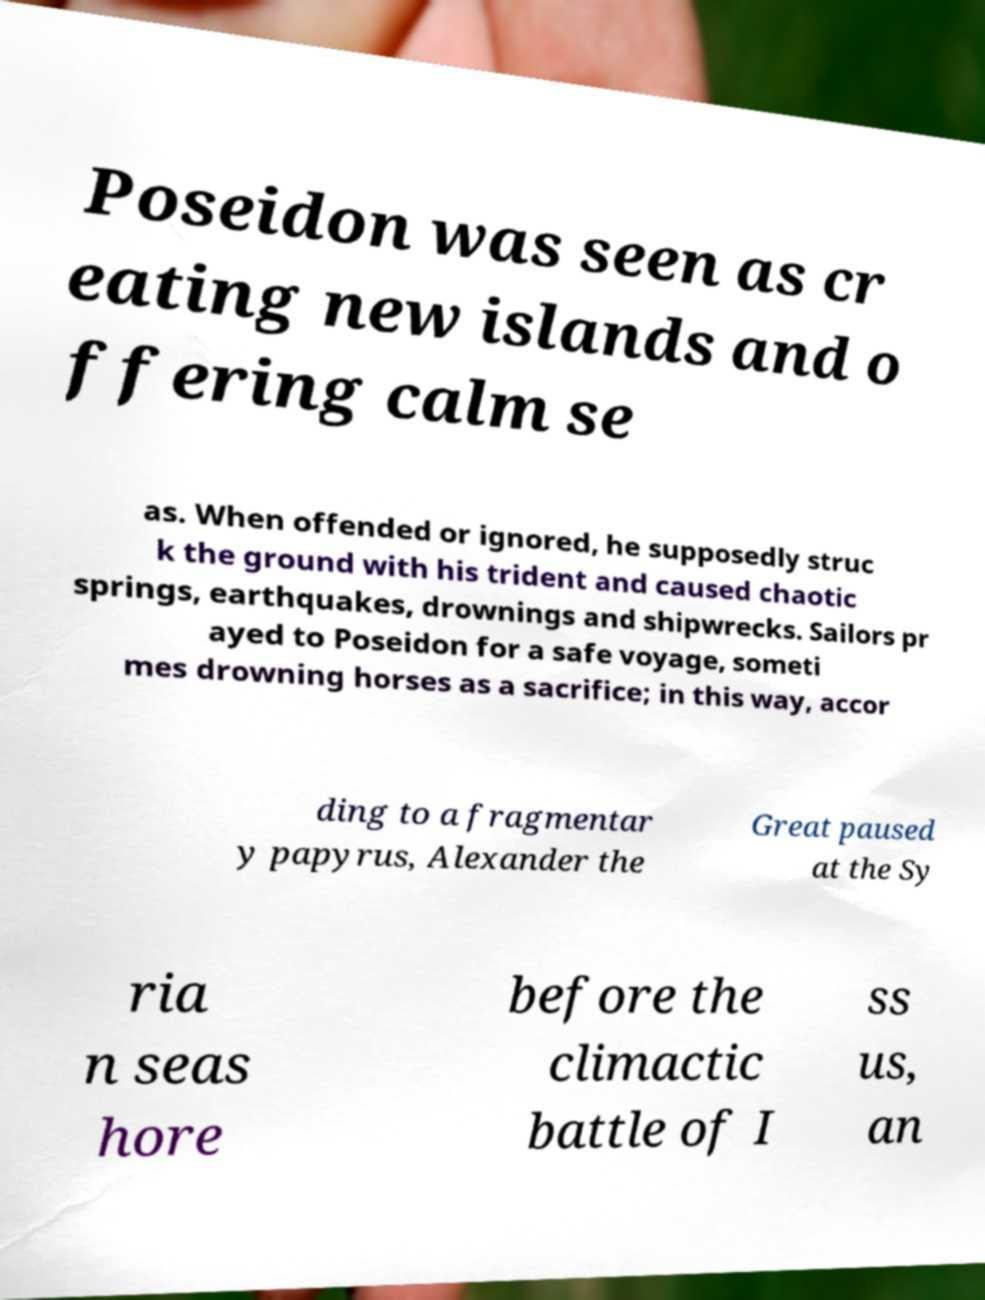Could you extract and type out the text from this image? Poseidon was seen as cr eating new islands and o ffering calm se as. When offended or ignored, he supposedly struc k the ground with his trident and caused chaotic springs, earthquakes, drownings and shipwrecks. Sailors pr ayed to Poseidon for a safe voyage, someti mes drowning horses as a sacrifice; in this way, accor ding to a fragmentar y papyrus, Alexander the Great paused at the Sy ria n seas hore before the climactic battle of I ss us, an 